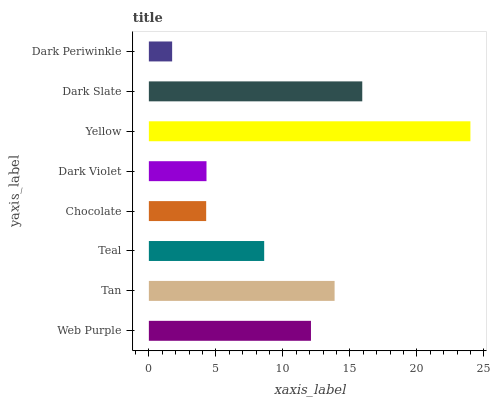Is Dark Periwinkle the minimum?
Answer yes or no. Yes. Is Yellow the maximum?
Answer yes or no. Yes. Is Tan the minimum?
Answer yes or no. No. Is Tan the maximum?
Answer yes or no. No. Is Tan greater than Web Purple?
Answer yes or no. Yes. Is Web Purple less than Tan?
Answer yes or no. Yes. Is Web Purple greater than Tan?
Answer yes or no. No. Is Tan less than Web Purple?
Answer yes or no. No. Is Web Purple the high median?
Answer yes or no. Yes. Is Teal the low median?
Answer yes or no. Yes. Is Dark Violet the high median?
Answer yes or no. No. Is Tan the low median?
Answer yes or no. No. 